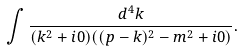Convert formula to latex. <formula><loc_0><loc_0><loc_500><loc_500>\int \frac { d ^ { 4 } k } { ( k ^ { 2 } + i 0 ) ( ( p - k ) ^ { 2 } - m ^ { 2 } + i 0 ) } .</formula> 